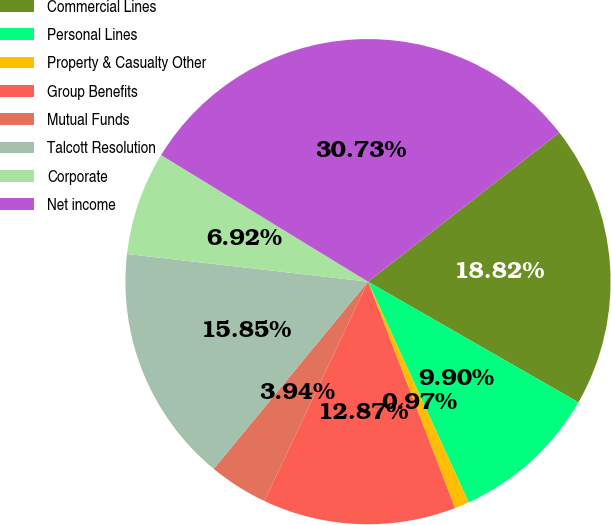Convert chart. <chart><loc_0><loc_0><loc_500><loc_500><pie_chart><fcel>Commercial Lines<fcel>Personal Lines<fcel>Property & Casualty Other<fcel>Group Benefits<fcel>Mutual Funds<fcel>Talcott Resolution<fcel>Corporate<fcel>Net income<nl><fcel>18.82%<fcel>9.9%<fcel>0.97%<fcel>12.87%<fcel>3.94%<fcel>15.85%<fcel>6.92%<fcel>30.73%<nl></chart> 